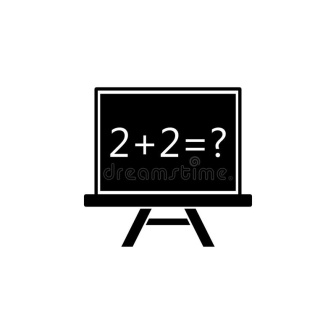What might the chalkboard and the equation symbolize in a philosophical context? In a philosophical context, the chalkboard and the equation '2 + 2 = ?' could symbolize the quest for knowledge and the fundamental nature of truth. The simplicity of the equation represents basic truths that are universally acknowledged, yet the question mark invites deeper reflection, questioning even the most straightforward aspects of reality. This scene could symbolize the human tendency to seek understanding and the endless pursuit of answers in a complex, often ambiguous world. The chalkboard, blank except for the equation, reflects the uncharted territory of knowledge waiting to be explored. 